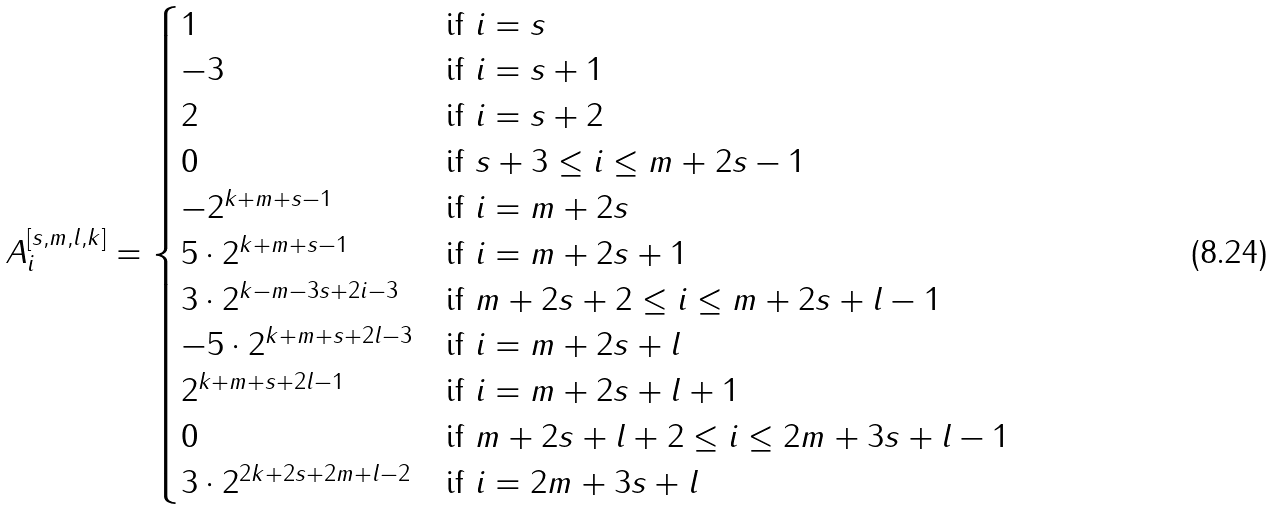Convert formula to latex. <formula><loc_0><loc_0><loc_500><loc_500>A _ { i } ^ { [ s , m , l , k ] } = \begin{cases} 1 & \text {if } i = s \\ - 3 & \text {if } i = s + 1 \\ 2 & \text {if } i = s + 2 \\ 0 & \text {if } s + 3 \leq i \leq m + 2 s - 1 \\ - 2 ^ { k + m + s - 1 } & \text {if } i = m + 2 s \\ 5 \cdot 2 ^ { k + m + s - 1 } & \text {if } i = m + 2 s + 1 \\ 3 \cdot 2 ^ { k - m - 3 s + 2 i - 3 } & \text {if } m + 2 s + 2 \leq i \leq m + 2 s + l - 1 \\ - 5 \cdot 2 ^ { k + m + s + 2 l - 3 } & \text {if } i = m + 2 s + l \\ 2 ^ { k + m + s + 2 l - 1 } & \text {if } i = m + 2 s + l + 1 \\ 0 & \text {if } m + 2 s + l + 2 \leq i \leq 2 m + 3 s + l - 1 \\ 3 \cdot 2 ^ { 2 k + 2 s + 2 m + l - 2 } & \text {if } i = 2 m + 3 s + l \end{cases}</formula> 